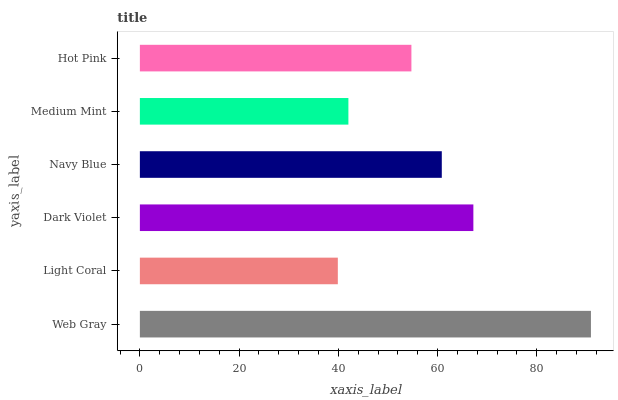Is Light Coral the minimum?
Answer yes or no. Yes. Is Web Gray the maximum?
Answer yes or no. Yes. Is Dark Violet the minimum?
Answer yes or no. No. Is Dark Violet the maximum?
Answer yes or no. No. Is Dark Violet greater than Light Coral?
Answer yes or no. Yes. Is Light Coral less than Dark Violet?
Answer yes or no. Yes. Is Light Coral greater than Dark Violet?
Answer yes or no. No. Is Dark Violet less than Light Coral?
Answer yes or no. No. Is Navy Blue the high median?
Answer yes or no. Yes. Is Hot Pink the low median?
Answer yes or no. Yes. Is Hot Pink the high median?
Answer yes or no. No. Is Web Gray the low median?
Answer yes or no. No. 